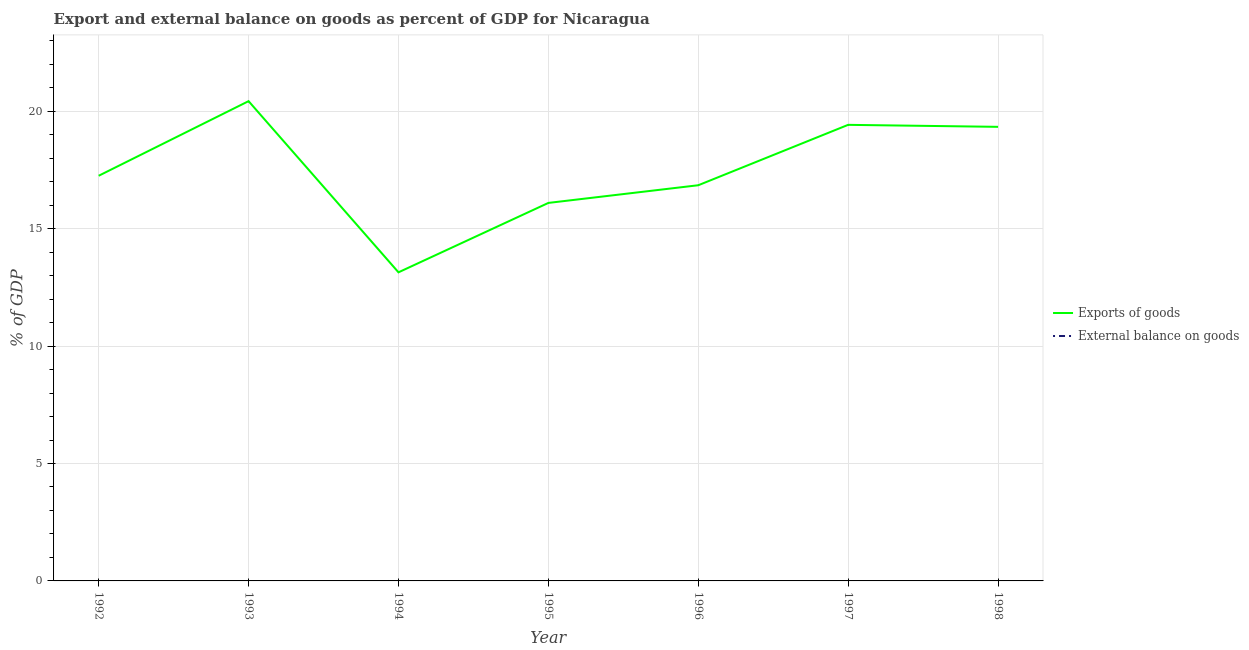How many different coloured lines are there?
Keep it short and to the point. 1. Does the line corresponding to export of goods as percentage of gdp intersect with the line corresponding to external balance on goods as percentage of gdp?
Your answer should be compact. No. Across all years, what is the maximum export of goods as percentage of gdp?
Your answer should be very brief. 20.43. Across all years, what is the minimum export of goods as percentage of gdp?
Give a very brief answer. 13.14. In which year was the export of goods as percentage of gdp maximum?
Provide a succinct answer. 1993. What is the total export of goods as percentage of gdp in the graph?
Ensure brevity in your answer.  122.52. What is the difference between the export of goods as percentage of gdp in 1993 and that in 1998?
Ensure brevity in your answer.  1.09. What is the difference between the export of goods as percentage of gdp in 1994 and the external balance on goods as percentage of gdp in 1995?
Make the answer very short. 13.14. What is the average export of goods as percentage of gdp per year?
Offer a terse response. 17.5. What is the ratio of the export of goods as percentage of gdp in 1992 to that in 1993?
Your response must be concise. 0.84. Is the export of goods as percentage of gdp in 1995 less than that in 1998?
Keep it short and to the point. Yes. What is the difference between the highest and the second highest export of goods as percentage of gdp?
Ensure brevity in your answer.  1.01. Is the sum of the export of goods as percentage of gdp in 1992 and 1994 greater than the maximum external balance on goods as percentage of gdp across all years?
Ensure brevity in your answer.  Yes. Does the export of goods as percentage of gdp monotonically increase over the years?
Keep it short and to the point. No. Is the external balance on goods as percentage of gdp strictly greater than the export of goods as percentage of gdp over the years?
Your answer should be very brief. No. Is the external balance on goods as percentage of gdp strictly less than the export of goods as percentage of gdp over the years?
Make the answer very short. Yes. How many lines are there?
Keep it short and to the point. 1. How many years are there in the graph?
Offer a very short reply. 7. Does the graph contain any zero values?
Provide a short and direct response. Yes. Does the graph contain grids?
Your answer should be very brief. Yes. How are the legend labels stacked?
Offer a terse response. Vertical. What is the title of the graph?
Ensure brevity in your answer.  Export and external balance on goods as percent of GDP for Nicaragua. What is the label or title of the X-axis?
Ensure brevity in your answer.  Year. What is the label or title of the Y-axis?
Give a very brief answer. % of GDP. What is the % of GDP in Exports of goods in 1992?
Offer a very short reply. 17.25. What is the % of GDP in Exports of goods in 1993?
Give a very brief answer. 20.43. What is the % of GDP of External balance on goods in 1993?
Your response must be concise. 0. What is the % of GDP in Exports of goods in 1994?
Offer a very short reply. 13.14. What is the % of GDP of External balance on goods in 1994?
Make the answer very short. 0. What is the % of GDP of Exports of goods in 1995?
Offer a terse response. 16.1. What is the % of GDP of External balance on goods in 1995?
Provide a succinct answer. 0. What is the % of GDP of Exports of goods in 1996?
Offer a very short reply. 16.85. What is the % of GDP of External balance on goods in 1996?
Make the answer very short. 0. What is the % of GDP of Exports of goods in 1997?
Your answer should be very brief. 19.42. What is the % of GDP of Exports of goods in 1998?
Ensure brevity in your answer.  19.33. What is the % of GDP of External balance on goods in 1998?
Offer a very short reply. 0. Across all years, what is the maximum % of GDP in Exports of goods?
Offer a very short reply. 20.43. Across all years, what is the minimum % of GDP in Exports of goods?
Provide a short and direct response. 13.14. What is the total % of GDP in Exports of goods in the graph?
Make the answer very short. 122.52. What is the total % of GDP of External balance on goods in the graph?
Your response must be concise. 0. What is the difference between the % of GDP of Exports of goods in 1992 and that in 1993?
Make the answer very short. -3.18. What is the difference between the % of GDP of Exports of goods in 1992 and that in 1994?
Offer a terse response. 4.11. What is the difference between the % of GDP in Exports of goods in 1992 and that in 1995?
Provide a short and direct response. 1.16. What is the difference between the % of GDP in Exports of goods in 1992 and that in 1996?
Ensure brevity in your answer.  0.4. What is the difference between the % of GDP in Exports of goods in 1992 and that in 1997?
Offer a very short reply. -2.17. What is the difference between the % of GDP in Exports of goods in 1992 and that in 1998?
Offer a very short reply. -2.08. What is the difference between the % of GDP in Exports of goods in 1993 and that in 1994?
Offer a terse response. 7.29. What is the difference between the % of GDP in Exports of goods in 1993 and that in 1995?
Make the answer very short. 4.33. What is the difference between the % of GDP of Exports of goods in 1993 and that in 1996?
Your response must be concise. 3.58. What is the difference between the % of GDP in Exports of goods in 1993 and that in 1997?
Your answer should be very brief. 1.01. What is the difference between the % of GDP of Exports of goods in 1993 and that in 1998?
Make the answer very short. 1.09. What is the difference between the % of GDP in Exports of goods in 1994 and that in 1995?
Your answer should be very brief. -2.96. What is the difference between the % of GDP in Exports of goods in 1994 and that in 1996?
Offer a terse response. -3.71. What is the difference between the % of GDP in Exports of goods in 1994 and that in 1997?
Your answer should be compact. -6.28. What is the difference between the % of GDP of Exports of goods in 1994 and that in 1998?
Your response must be concise. -6.19. What is the difference between the % of GDP in Exports of goods in 1995 and that in 1996?
Your answer should be compact. -0.75. What is the difference between the % of GDP of Exports of goods in 1995 and that in 1997?
Keep it short and to the point. -3.32. What is the difference between the % of GDP in Exports of goods in 1995 and that in 1998?
Offer a terse response. -3.24. What is the difference between the % of GDP of Exports of goods in 1996 and that in 1997?
Your response must be concise. -2.57. What is the difference between the % of GDP in Exports of goods in 1996 and that in 1998?
Provide a short and direct response. -2.49. What is the difference between the % of GDP of Exports of goods in 1997 and that in 1998?
Give a very brief answer. 0.09. What is the average % of GDP in Exports of goods per year?
Your answer should be very brief. 17.5. What is the average % of GDP of External balance on goods per year?
Provide a short and direct response. 0. What is the ratio of the % of GDP in Exports of goods in 1992 to that in 1993?
Ensure brevity in your answer.  0.84. What is the ratio of the % of GDP in Exports of goods in 1992 to that in 1994?
Ensure brevity in your answer.  1.31. What is the ratio of the % of GDP of Exports of goods in 1992 to that in 1995?
Offer a very short reply. 1.07. What is the ratio of the % of GDP of Exports of goods in 1992 to that in 1997?
Offer a very short reply. 0.89. What is the ratio of the % of GDP in Exports of goods in 1992 to that in 1998?
Your answer should be very brief. 0.89. What is the ratio of the % of GDP of Exports of goods in 1993 to that in 1994?
Your response must be concise. 1.55. What is the ratio of the % of GDP of Exports of goods in 1993 to that in 1995?
Your response must be concise. 1.27. What is the ratio of the % of GDP of Exports of goods in 1993 to that in 1996?
Make the answer very short. 1.21. What is the ratio of the % of GDP in Exports of goods in 1993 to that in 1997?
Your answer should be very brief. 1.05. What is the ratio of the % of GDP of Exports of goods in 1993 to that in 1998?
Ensure brevity in your answer.  1.06. What is the ratio of the % of GDP in Exports of goods in 1994 to that in 1995?
Offer a terse response. 0.82. What is the ratio of the % of GDP of Exports of goods in 1994 to that in 1996?
Your answer should be compact. 0.78. What is the ratio of the % of GDP of Exports of goods in 1994 to that in 1997?
Give a very brief answer. 0.68. What is the ratio of the % of GDP of Exports of goods in 1994 to that in 1998?
Provide a short and direct response. 0.68. What is the ratio of the % of GDP in Exports of goods in 1995 to that in 1996?
Make the answer very short. 0.96. What is the ratio of the % of GDP in Exports of goods in 1995 to that in 1997?
Make the answer very short. 0.83. What is the ratio of the % of GDP of Exports of goods in 1995 to that in 1998?
Provide a short and direct response. 0.83. What is the ratio of the % of GDP in Exports of goods in 1996 to that in 1997?
Provide a succinct answer. 0.87. What is the ratio of the % of GDP in Exports of goods in 1996 to that in 1998?
Your answer should be compact. 0.87. What is the difference between the highest and the second highest % of GDP of Exports of goods?
Your answer should be compact. 1.01. What is the difference between the highest and the lowest % of GDP in Exports of goods?
Keep it short and to the point. 7.29. 